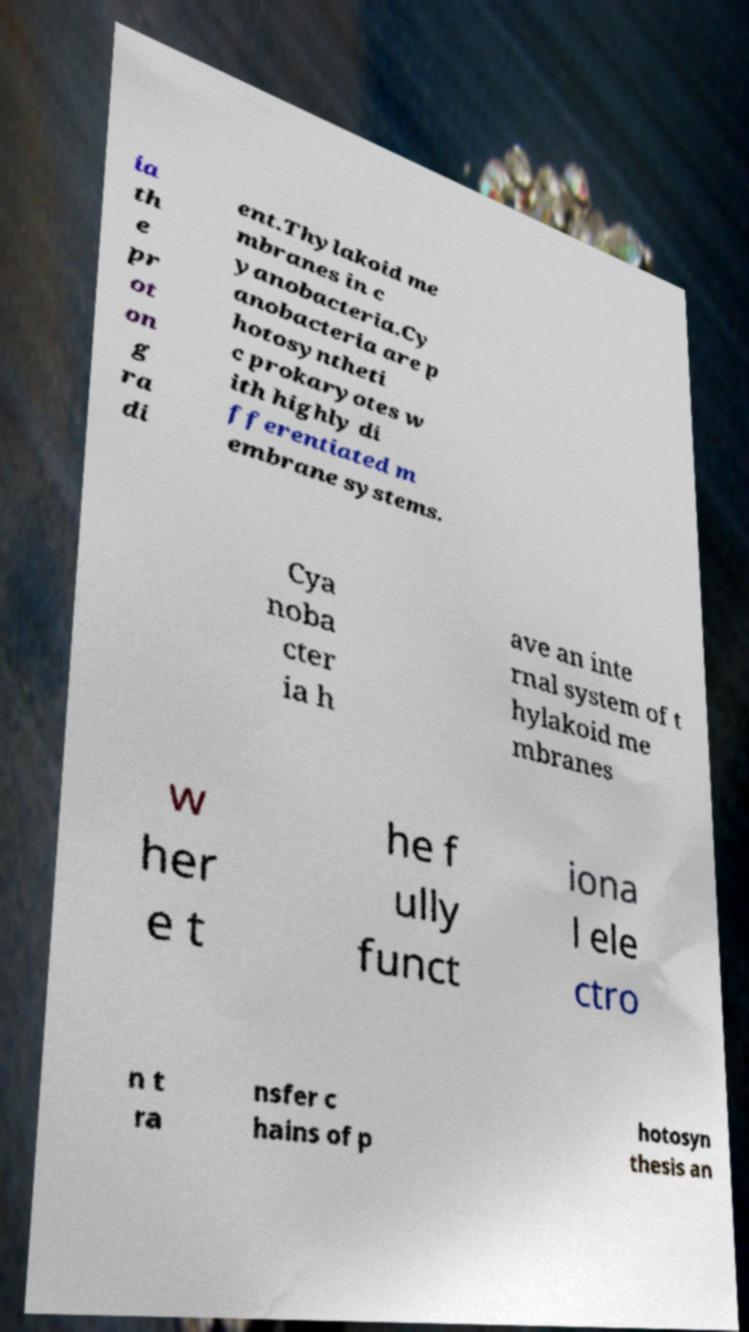Can you read and provide the text displayed in the image?This photo seems to have some interesting text. Can you extract and type it out for me? ia th e pr ot on g ra di ent.Thylakoid me mbranes in c yanobacteria.Cy anobacteria are p hotosyntheti c prokaryotes w ith highly di fferentiated m embrane systems. Cya noba cter ia h ave an inte rnal system of t hylakoid me mbranes w her e t he f ully funct iona l ele ctro n t ra nsfer c hains of p hotosyn thesis an 